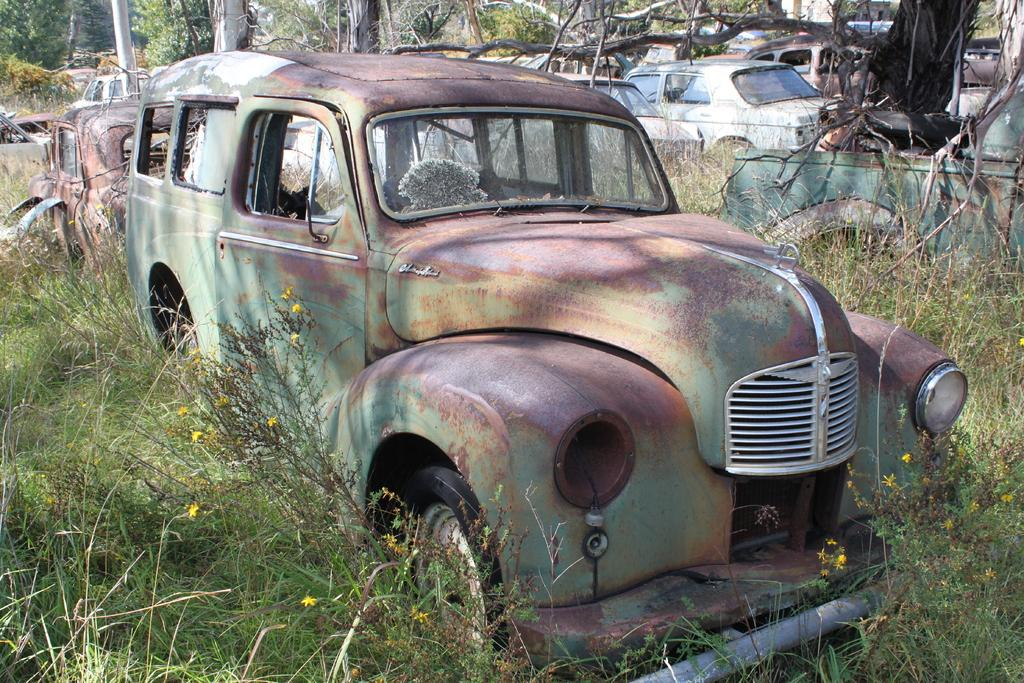What types of objects are present in the image? There are vehicles in the image. What is covering the vehicles? There is junk on the vehicles. What type of natural environment can be seen in the image? There is grass visible in the image. What structure is present in the image? There is a pole in the image. What other living organisms are present in the image? There are plants in the image. What reward is being given to the land in the image? There is no mention of a reward or land in the image; it features vehicles with junk on them, grass, a pole, and plants. 